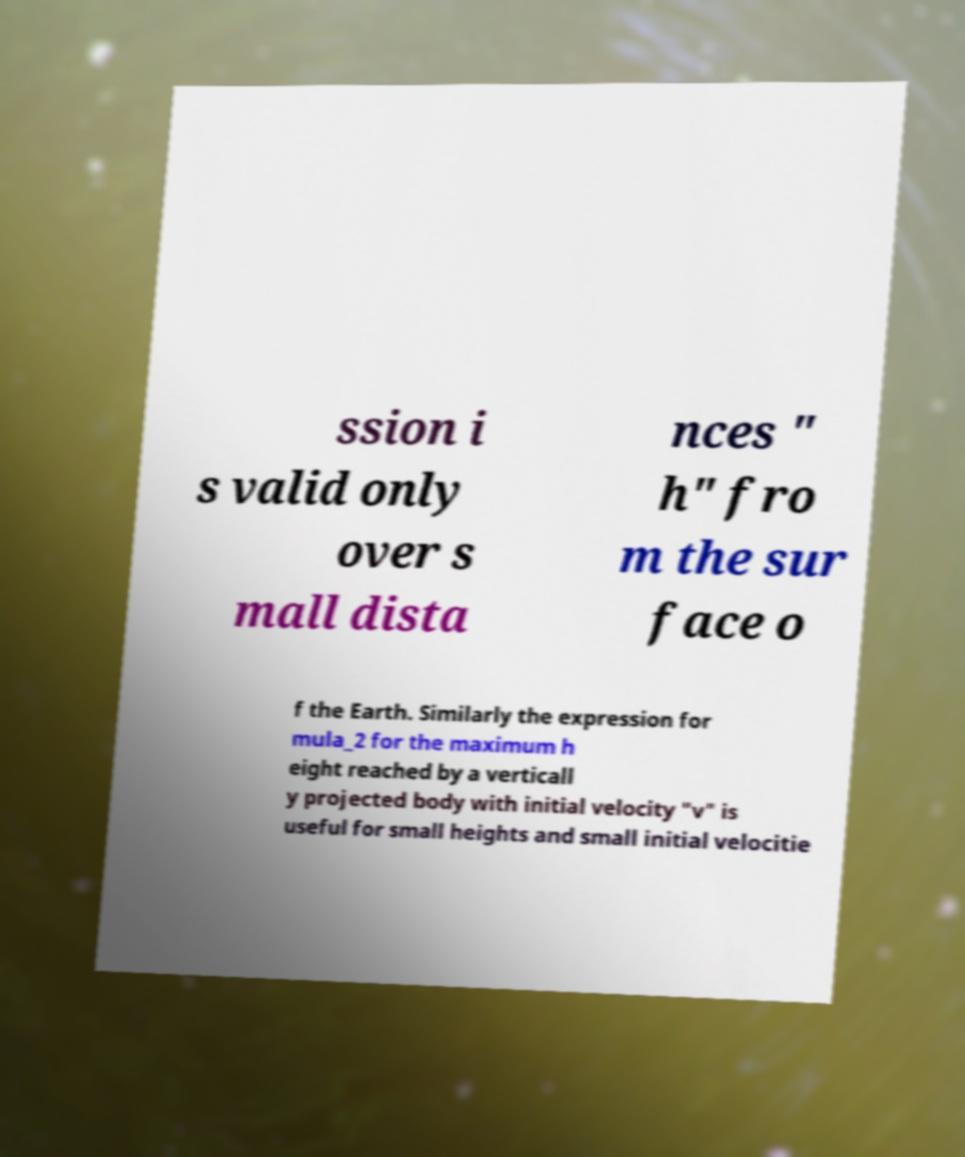For documentation purposes, I need the text within this image transcribed. Could you provide that? ssion i s valid only over s mall dista nces " h" fro m the sur face o f the Earth. Similarly the expression for mula_2 for the maximum h eight reached by a verticall y projected body with initial velocity "v" is useful for small heights and small initial velocitie 